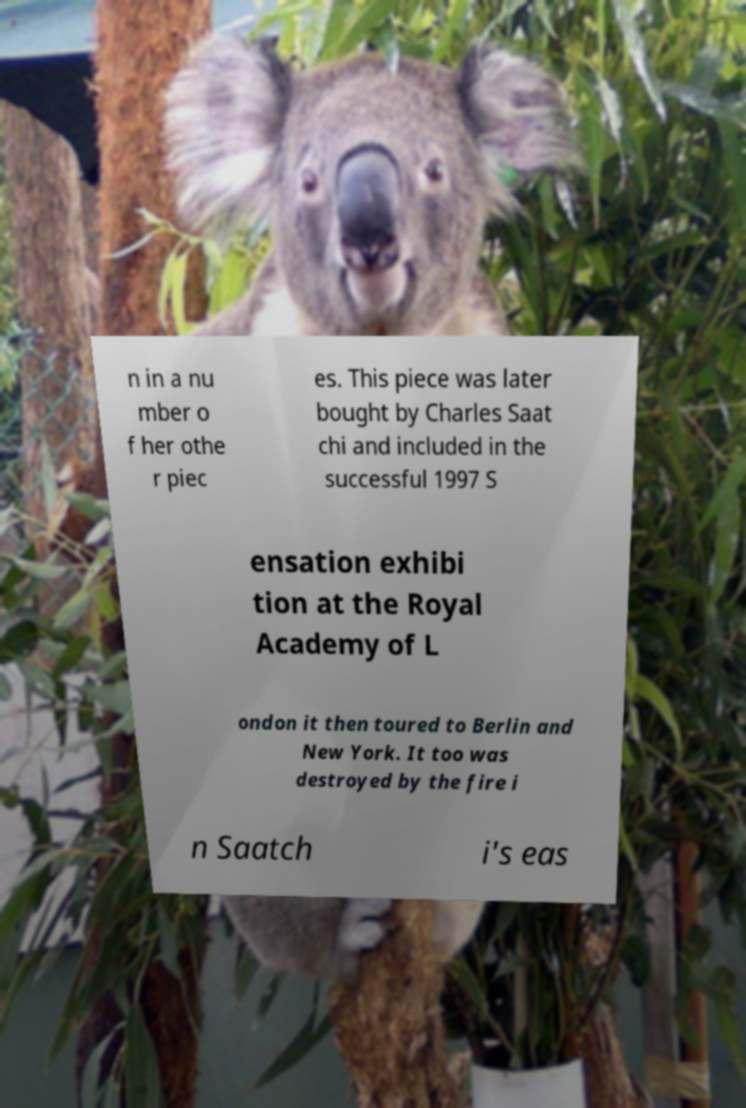There's text embedded in this image that I need extracted. Can you transcribe it verbatim? n in a nu mber o f her othe r piec es. This piece was later bought by Charles Saat chi and included in the successful 1997 S ensation exhibi tion at the Royal Academy of L ondon it then toured to Berlin and New York. It too was destroyed by the fire i n Saatch i's eas 